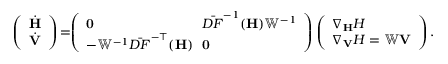Convert formula to latex. <formula><loc_0><loc_0><loc_500><loc_500>\begin{array} { r l } & { \left ( \begin{array} { l } { \dot { H } } \\ { \dot { V } } \end{array} \right ) \, = \, \left ( \begin{array} { l l } { { 0 } \, } & { \bar { D F } ^ { - 1 } ( { \mathbf H } ) { \mathbb { W } } ^ { - 1 } } \\ { - { \mathbb { W } } ^ { - 1 } \bar { D F } ^ { - \top } ( { \mathbf H } ) \, } & { \mathbf 0 } \end{array} \right ) \left ( \begin{array} { l } { \nabla _ { H } H } \\ { \nabla _ { V } H = \mathbb { W } { \mathbf V } } \end{array} \right ) . } \end{array}</formula> 